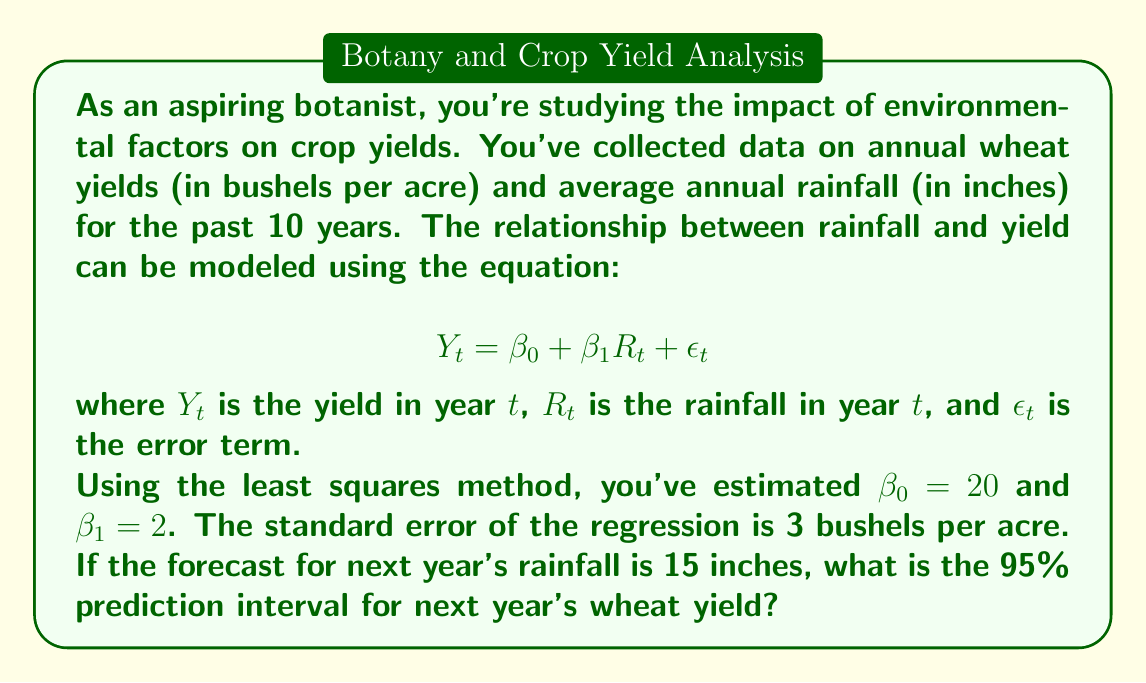Provide a solution to this math problem. To solve this problem, we'll follow these steps:

1) First, let's recall the formula for a prediction interval:

   $$\hat{Y} \pm t_{\alpha/2, n-2} \cdot s_e \sqrt{1 + \frac{1}{n} + \frac{(X_h - \bar{X})^2}{\sum(X_i - \bar{X})^2}}$$

   where $\hat{Y}$ is the point forecast, $t_{\alpha/2, n-2}$ is the t-value for a 95% confidence level with n-2 degrees of freedom, $s_e$ is the standard error of the regression, $X_h$ is the value of X for which we're making the prediction, $\bar{X}$ is the mean of X in our sample, and $\sum(X_i - \bar{X})^2$ is the sum of squared deviations of X from its mean.

2) We're given that $\beta_0 = 20$, $\beta_1 = 2$, and the standard error $s_e = 3$.

3) The point forecast for next year's yield when rainfall is 15 inches is:

   $$\hat{Y} = \beta_0 + \beta_1 R_t = 20 + 2(15) = 50$$ bushels per acre

4) For a 95% prediction interval with 8 degrees of freedom (10 years of data minus 2 parameters), the t-value is approximately 2.306.

5) We don't have enough information to calculate the exact values for $\frac{1}{n} + \frac{(X_h - \bar{X})^2}{\sum(X_i - \bar{X})^2}$, but we know this term is always greater than or equal to $\frac{1}{n}$. In this case, $\frac{1}{n} = \frac{1}{10} = 0.1$.

6) Therefore, we can calculate a conservative prediction interval:

   $$50 \pm 2.306 \cdot 3 \sqrt{1 + 0.1} = 50 \pm 7.26$$

7) This gives us a prediction interval of (42.74, 57.26) bushels per acre.
Answer: The 95% prediction interval for next year's wheat yield is approximately (42.74, 57.26) bushels per acre. 